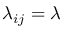<formula> <loc_0><loc_0><loc_500><loc_500>\lambda _ { i j } = \lambda</formula> 